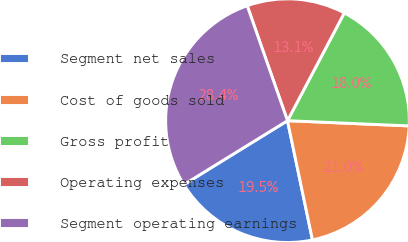Convert chart. <chart><loc_0><loc_0><loc_500><loc_500><pie_chart><fcel>Segment net sales<fcel>Cost of goods sold<fcel>Gross profit<fcel>Operating expenses<fcel>Segment operating earnings<nl><fcel>19.49%<fcel>21.03%<fcel>17.96%<fcel>13.09%<fcel>28.43%<nl></chart> 